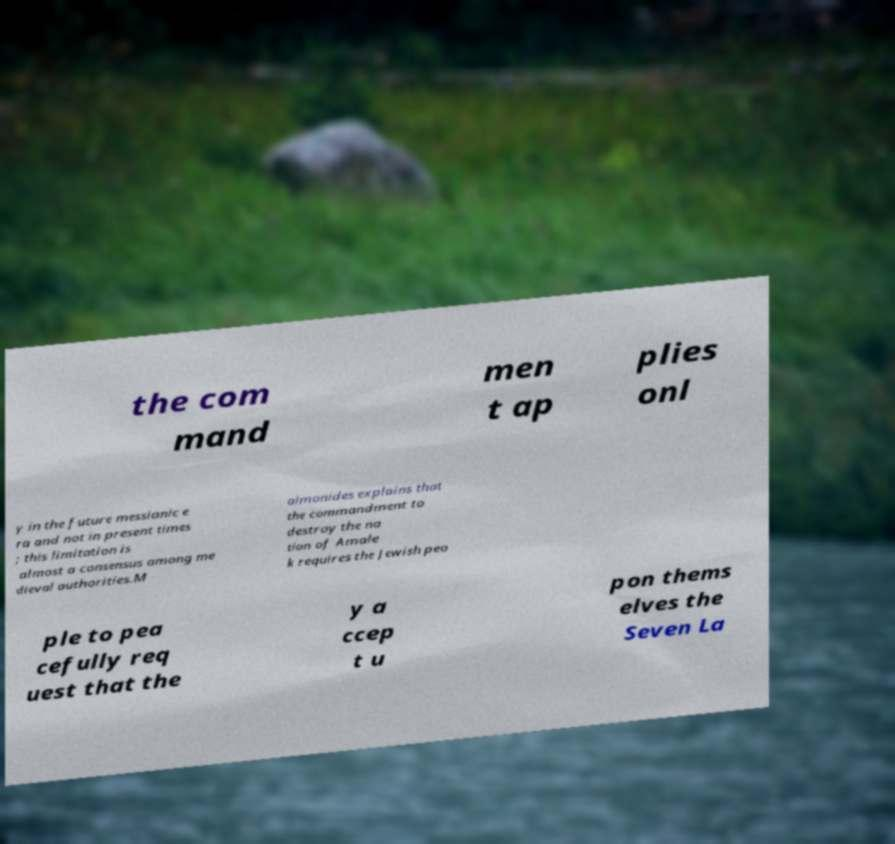Can you accurately transcribe the text from the provided image for me? the com mand men t ap plies onl y in the future messianic e ra and not in present times ; this limitation is almost a consensus among me dieval authorities.M aimonides explains that the commandment to destroy the na tion of Amale k requires the Jewish peo ple to pea cefully req uest that the y a ccep t u pon thems elves the Seven La 